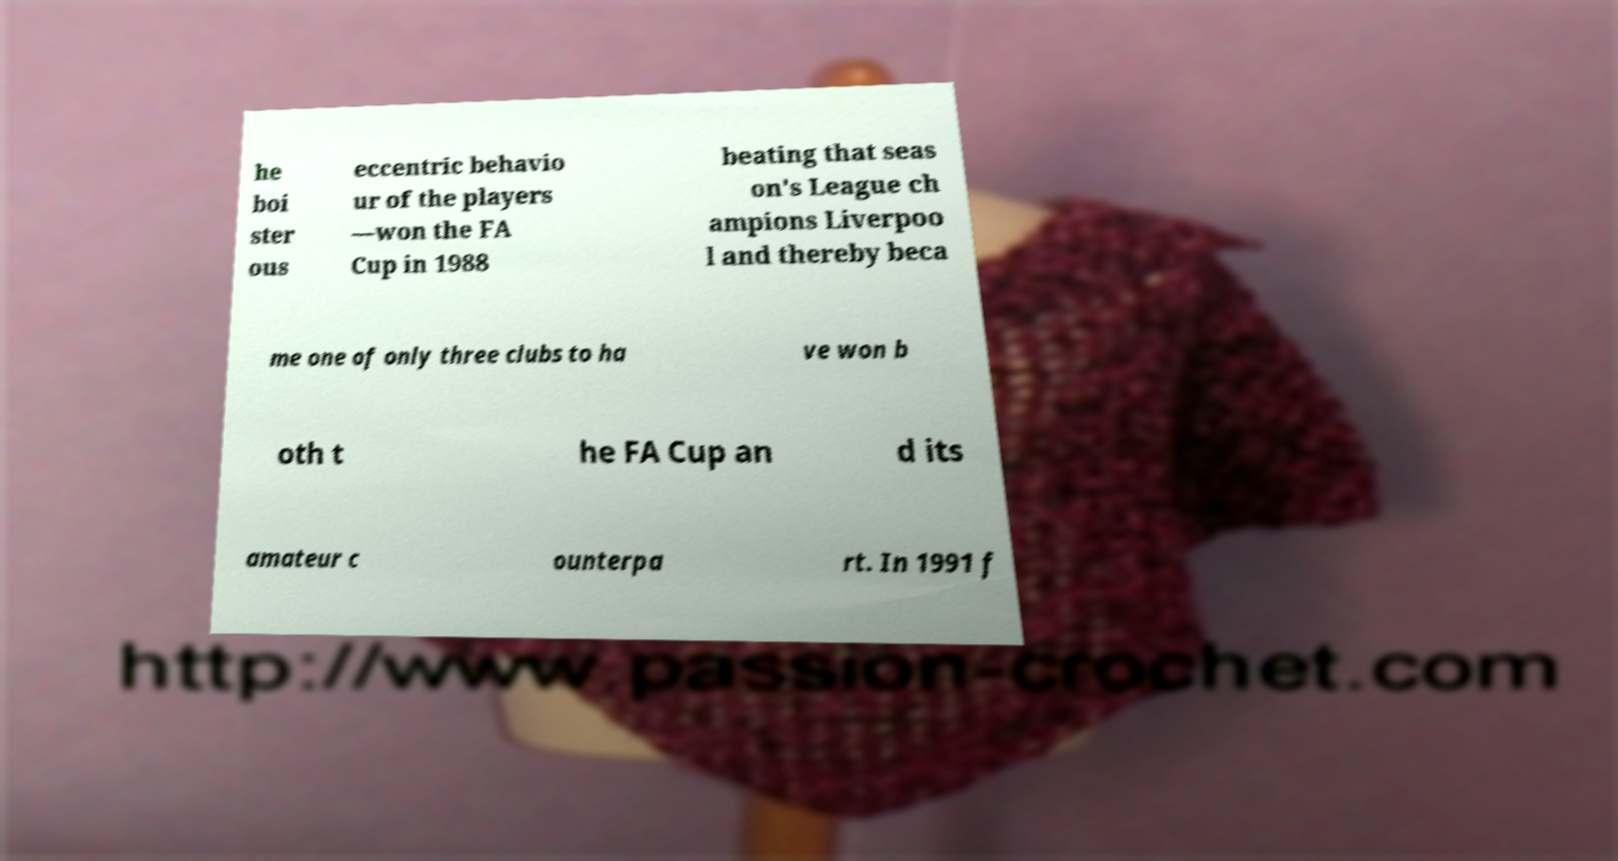Please identify and transcribe the text found in this image. he boi ster ous eccentric behavio ur of the players —won the FA Cup in 1988 beating that seas on's League ch ampions Liverpoo l and thereby beca me one of only three clubs to ha ve won b oth t he FA Cup an d its amateur c ounterpa rt. In 1991 f 